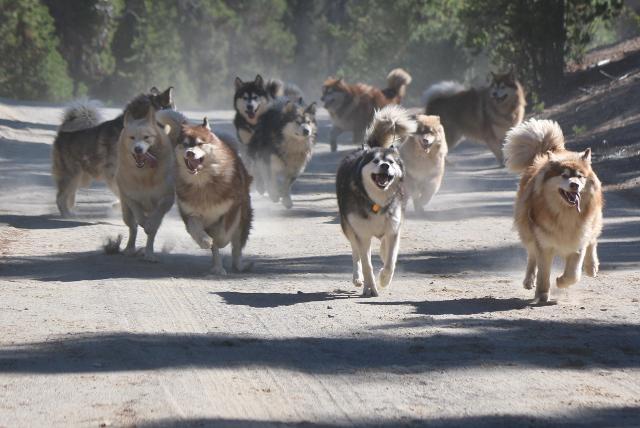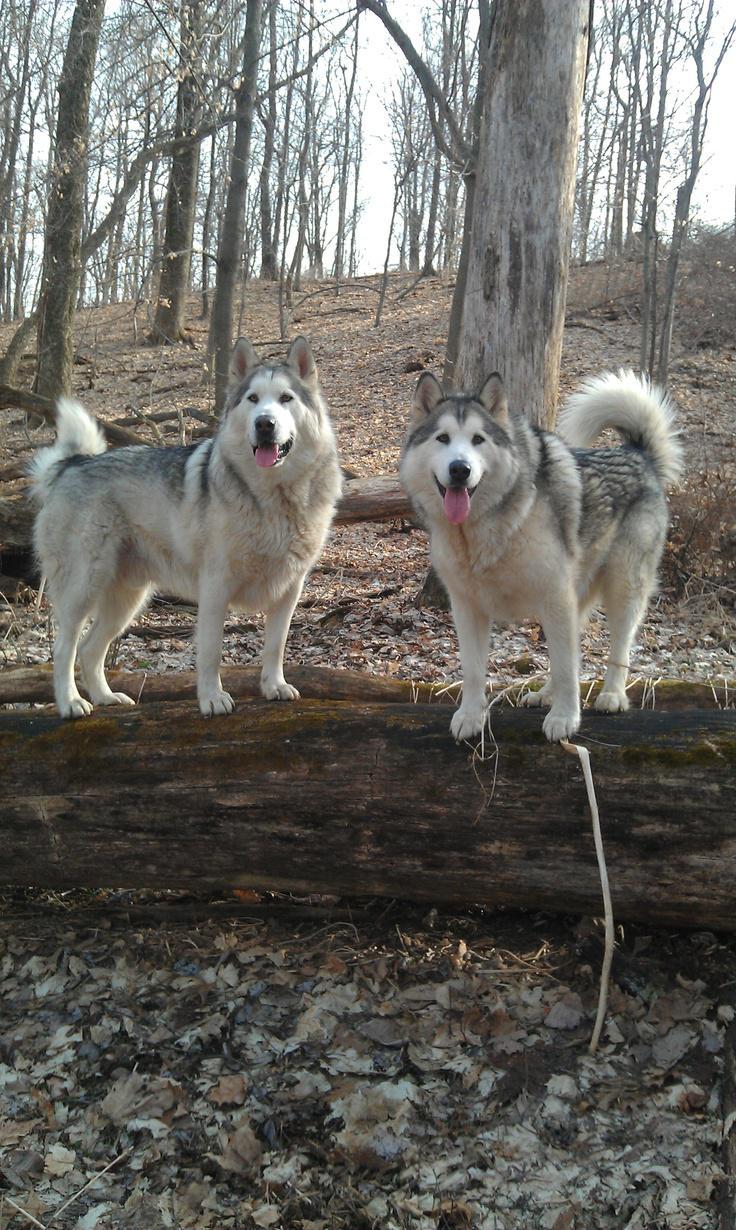The first image is the image on the left, the second image is the image on the right. Examine the images to the left and right. Is the description "The right image contains exactly one dog." accurate? Answer yes or no. No. The first image is the image on the left, the second image is the image on the right. Analyze the images presented: Is the assertion "The left image contains exactly two husky dogs of similar size and age posed with bodies turned leftward, mouths closed, and gazes matched." valid? Answer yes or no. No. 